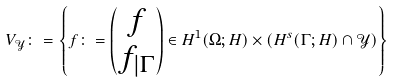Convert formula to latex. <formula><loc_0><loc_0><loc_500><loc_500>V _ { \mathcal { Y } } \colon = \left \{ { f } \colon = \begin{pmatrix} f \\ f _ { | \Gamma } \end{pmatrix} \in H ^ { 1 } ( \Omega ; H ) \times \left ( H ^ { s } ( \Gamma ; H ) \cap { \mathcal { Y } } \right ) \right \}</formula> 